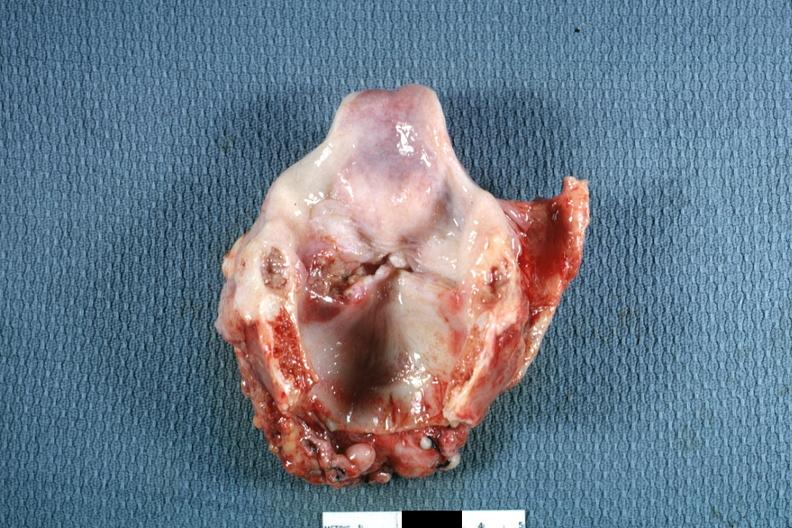s ulcerative lesion left true cord quite good?
Answer the question using a single word or phrase. Yes 